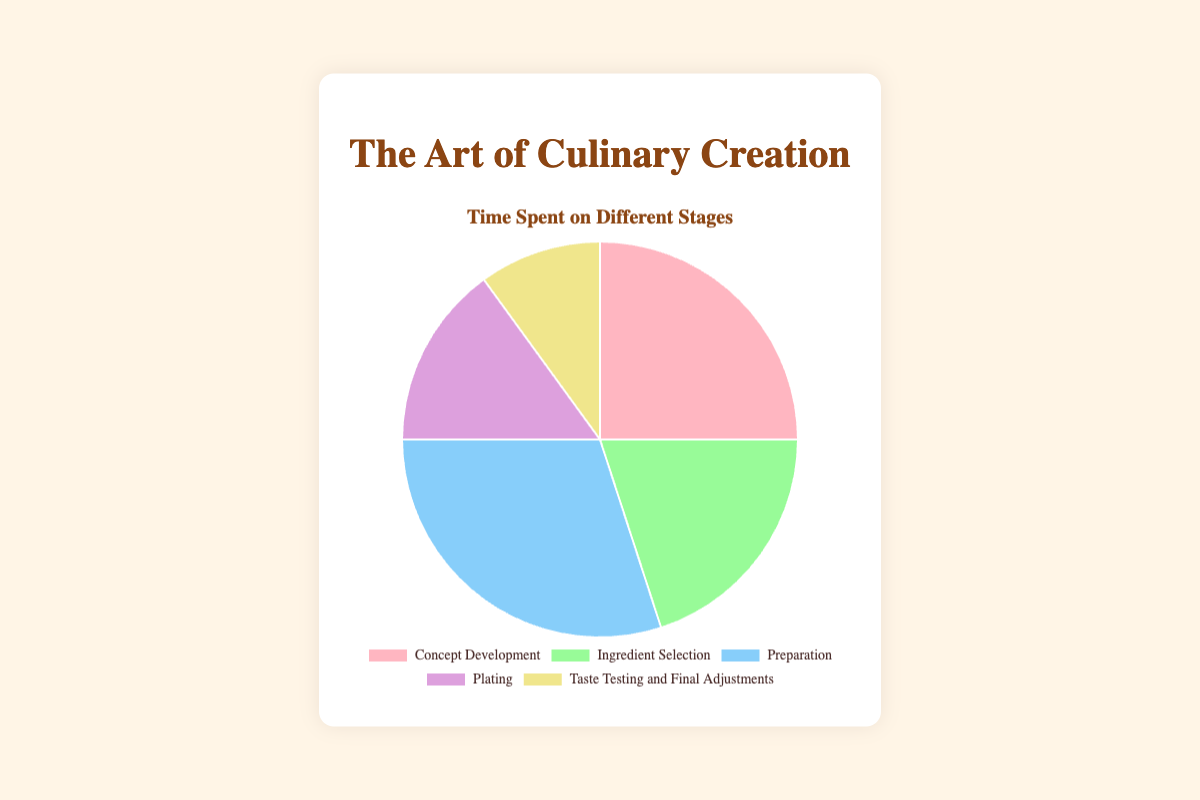Which stage takes the most time in the culinary creation process? Identify the stage with the highest percentage on the pie chart. 'Preparation' has the largest segment.
Answer: Preparation Which stage takes the least time in the culinary creation process? Identify the stage with the smallest percentage on the pie chart. 'Taste Testing and Final Adjustments' has the smallest segment.
Answer: Taste Testing and Final Adjustments How much more time is spent on Concept Development than on Plating? Subtract the percentage for Plating from the percentage for Concept Development: 25% - 15% = 10%.
Answer: 10% What’s the total percentage of time spent on stages involving hands-on work (Preparation and Plating)? Sum the percentages for Preparation and Plating: 30% + 15% = 45%.
Answer: 45% Is more time spent on Ingredient Selection or Taste Testing and Final Adjustments? Compare the percentages for Ingredient Selection and Taste Testing and Final Adjustments: 20% > 10%.
Answer: Ingredient Selection What is the difference in time spent between the stage with the highest percentage and the stage with the lowest percentage? Subtract the smallest percentage (Taste Testing and Final Adjustments) from the largest percentage (Preparation): 30% - 10% = 20%.
Answer: 20% How does the time spent on Ingredient Selection compare visually to the time spent on Taste Testing Observe the pie chart where the segment representing Ingredient Selection appears larger than the segment for Taste Testing and Final Adjustments. Ingredient Selection has a larger segment.
Answer: Ingredient Selection Considering only Concept Development and Ingredient Selection, what is their average time spent? We first add the percentages: 25% + 20% = 45%, then divide by 2 to find the average: 45% / 2 = 22.5%.
Answer: 22.5% What is the combined percentage of time spent on Concept Development, Ingredient Selection, and Taste Testing and Final Adjustments? Sum the percentages for these stages: 25% + 20% + 10% = 55%.
Answer: 55% What percentage of time is dedicated to non-preparation stages (excluding Preparation)? Subtract the Preparation stage percentage from the total (100%): 100% - 30% = 70%.
Answer: 70% 